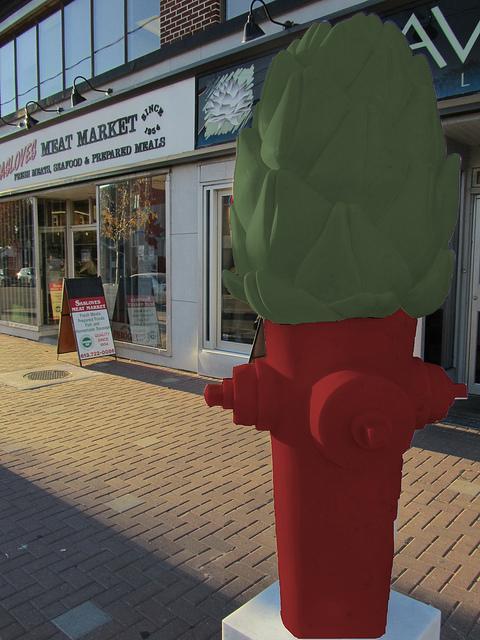How many keyboards are there?
Give a very brief answer. 0. 